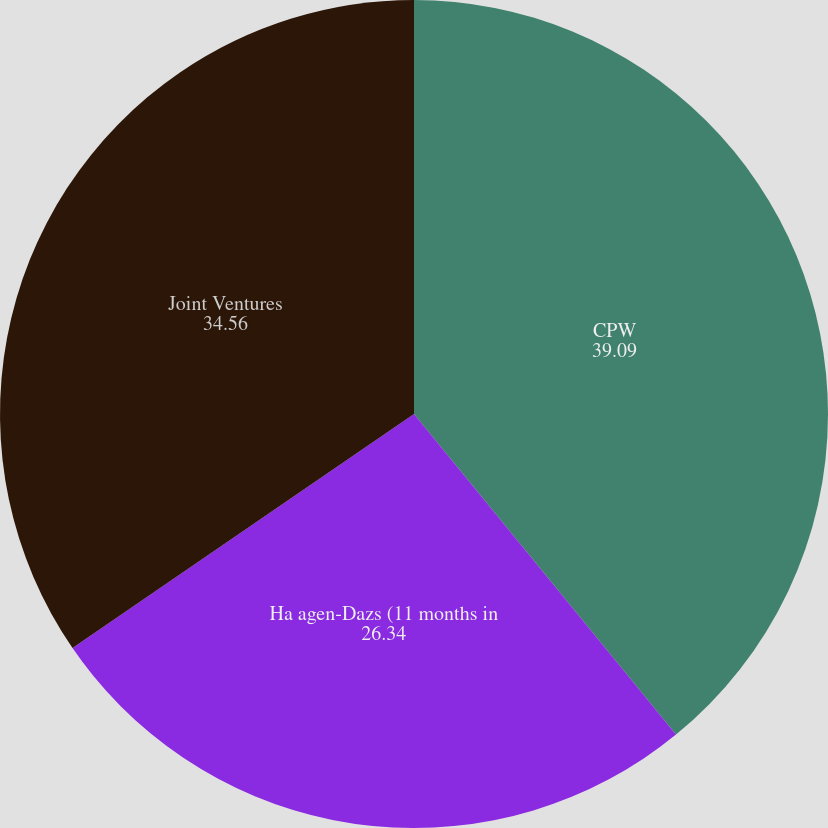Convert chart. <chart><loc_0><loc_0><loc_500><loc_500><pie_chart><fcel>CPW<fcel>Ha agen-Dazs (11 months in<fcel>Joint Ventures<nl><fcel>39.09%<fcel>26.34%<fcel>34.56%<nl></chart> 